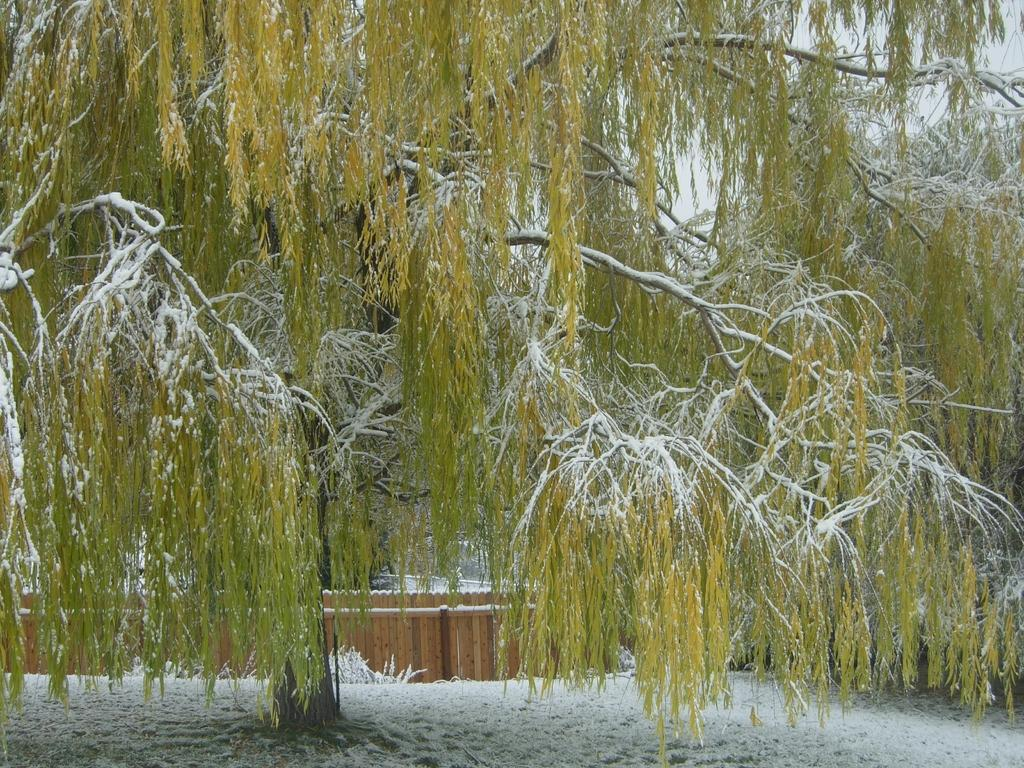What is the main object in the image? There is a tree in the image. What is covering the tree? The tree is covered with snow. Is there any snow visible at the bottom of the image? Yes, there is snow at the bottom of the image. What type of jeans is the frog wearing in the image? There is no frog or jeans present in the image; it features a tree covered with snow. 